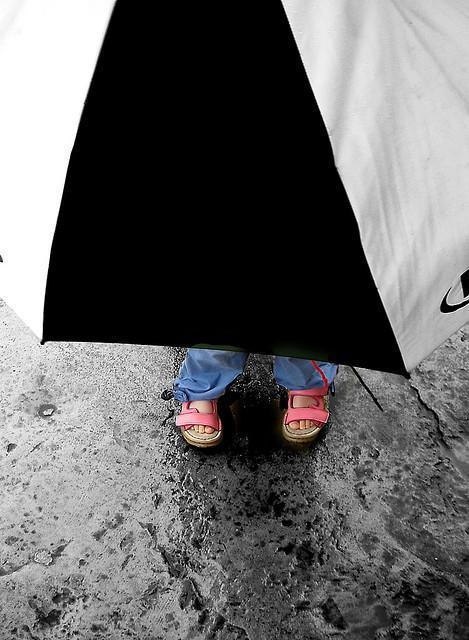Is the caption "The umbrella is over the person." a true representation of the image?
Answer yes or no. Yes. 